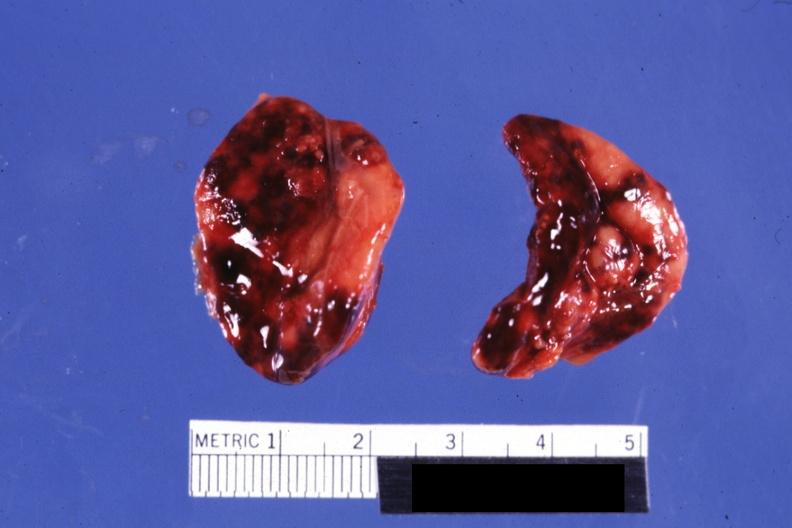does this image show both adrenals external views focal hemorrhages do not know history looks like placental abruption?
Answer the question using a single word or phrase. Yes 